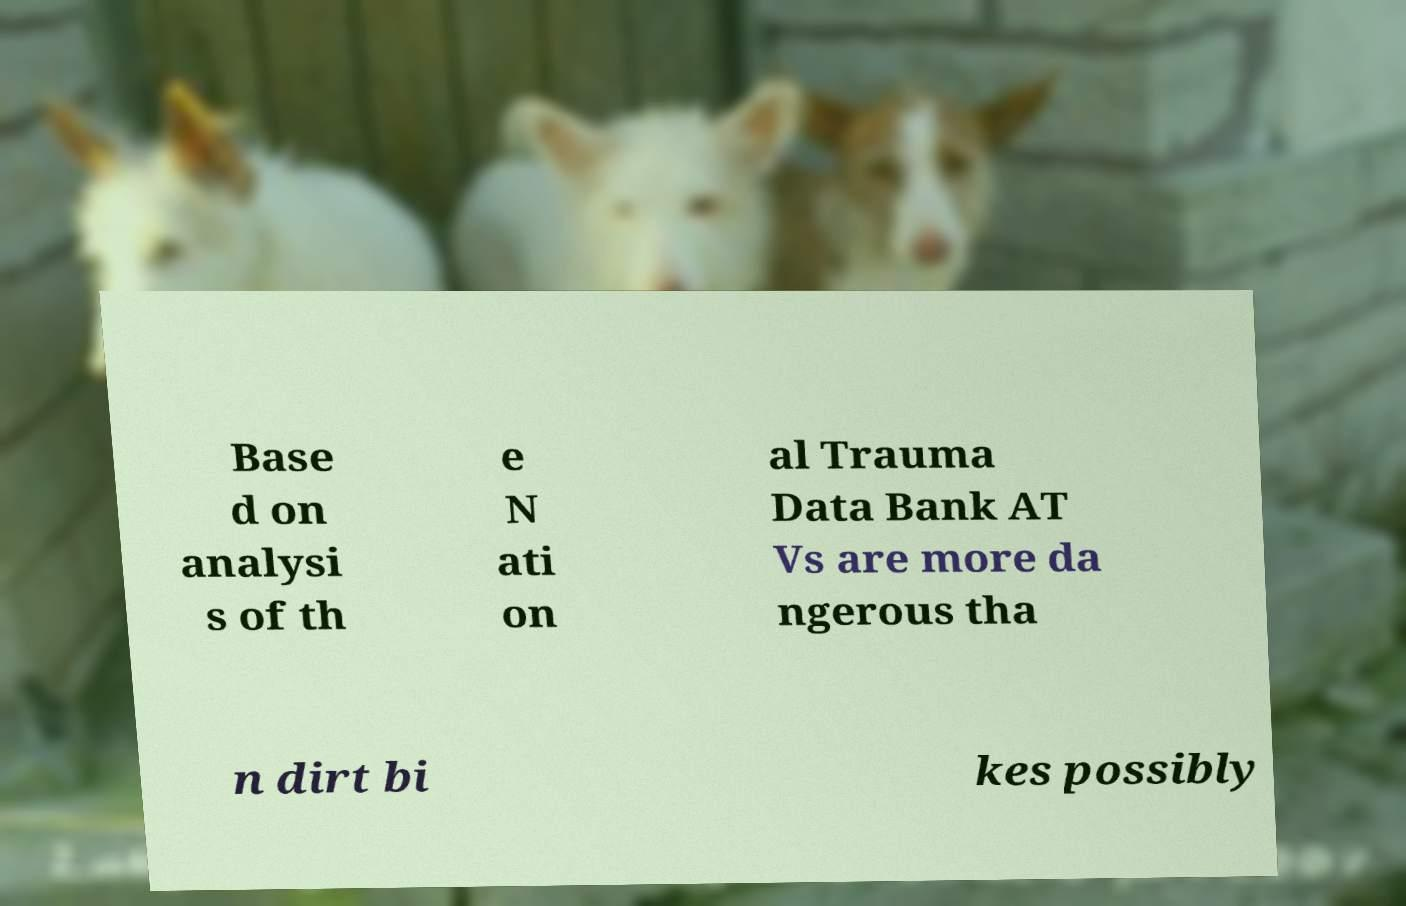Can you accurately transcribe the text from the provided image for me? Base d on analysi s of th e N ati on al Trauma Data Bank AT Vs are more da ngerous tha n dirt bi kes possibly 